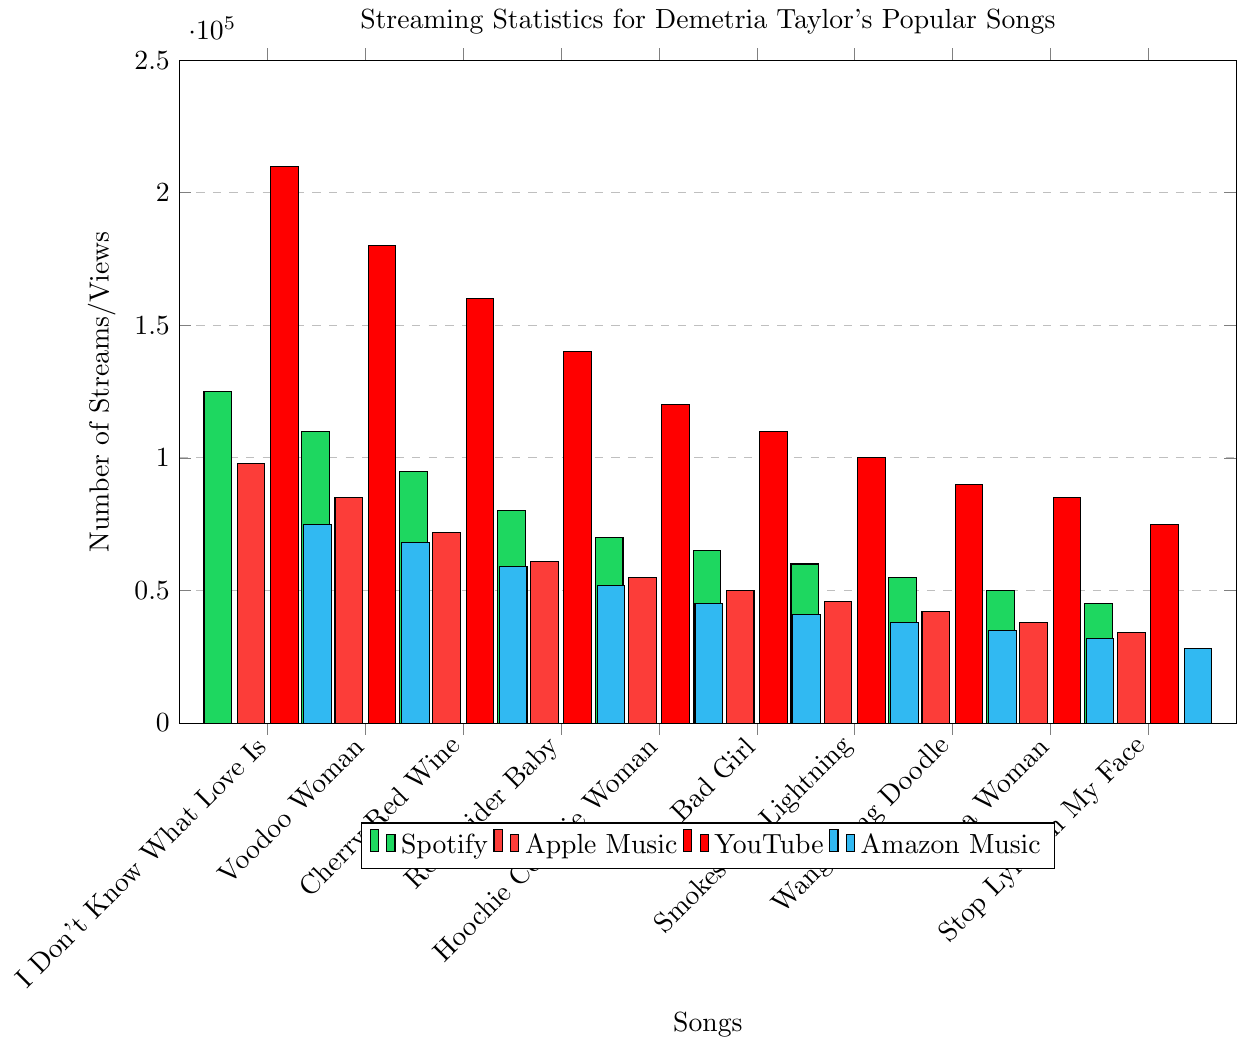Which song has the highest number of YouTube views? The heights of the bars in red (YouTube) indicate the number of views. The tallest red bar corresponds to the song "I Don't Know What Love Is" with 210,000 views.
Answer: "I Don't Know What Love Is" What is the sum of Spotify streams for "Voodoo Woman" and "Cherry Red Wine"? Add the number of Spotify streams for "Voodoo Woman" (110,000) and "Cherry Red Wine" (95,000). The sum is 110,000 + 95,000 = 205,000.
Answer: 205,000 Which song has the smallest number of Amazon Music streams? The heights of the bars in blue (Amazon Music) are compared to determine the smallest. The shortest blue bar corresponds to "Stop Lying in My Face" with 28,000 streams.
Answer: "Stop Lying in My Face" How does the number of Apple Music plays for "Bad Girl" compare to "Hoochie Coochie Woman"? The heights of bars in red for "Bad Girl" and "Hoochie Coochie Woman" are compared. "Bad Girl" has 50,000 plays, and "Hoochie Coochie Woman" has 55,000 plays, so "Bad Girl" has fewer plays.
Answer: Fewer Which song has more Spotify streams, "Smokestack Lightning" or "Wang Dang Doodle"? The heights of the green bars for both songs are compared. "Smokestack Lightning" has 60,000 streams, and "Wang Dang Doodle" has 55,000 streams, so "Smokestack Lightning" has more.
Answer: "Smokestack Lightning" What is the average number of YouTube views across all songs? First, add up all the YouTube views: 210,000 + 180,000 + 160,000 + 140,000 + 120,000 + 110,000 + 100,000 + 90,000 + 85,000 + 75,000 = 1,270,000. Then, divide by the number of songs (10). The average is 1,270,000 / 10 = 127,000.
Answer: 127,000 Which song has almost equal Spotify and Apple Music plays? Compare the heights of green and red bars for each song. "Cherry Red Wine" has 95,000 Spotify streams and 72,000 Apple Music plays, which are the closest in value among all songs.
Answer: "Cherry Red Wine" What is the difference in Amazon Music streams between "I'm a Woman" and "Stop Lying in My Face"? Subtract the number of Amazon Music streams for "Stop Lying in My Face" (28,000) from "I'm a Woman" (32,000). The difference is 32,000 - 28,000 = 4,000.
Answer: 4,000 Identify the song with the highest total streams across all platforms. Calculate the total streams for each song by summing up the streams/views for Spotify, Apple Music, YouTube, and Amazon Music. The song with the highest total will be the one with the sum:
"I Don't Know What Love Is" = 125,000 + 98,000 + 210,000 + 75,000 = 508,000
"Voodoo Woman" = 110,000 + 85,000 + 180,000 + 68,000 = 443,000
"Cherry Red Wine" = 95,000 + 72,000 + 160,000 + 59,000 = 386,000
"Reconsider Baby" = 80,000 + 61,000 + 140,000 + 52,000 = 333,000
"Hoochie Coochie Woman" = 70,000 + 55,000 + 120,000 + 45,000 = 290,000
"Bad Girl" = 65,000 + 50,000 + 110,000 + 41,000 = 266,000
"Smokestack Lightning" = 60,000 + 46,000 + 100,000 + 38,000 = 244,000
"Wang Dang Doodle" = 55,000 + 42,000 + 90,000 + 35,000 = 222,000
"I'm a Woman" = 50,000 + 38,000 + 85,000 + 32,000 = 205,000
"Stop Lying in My Face" = 45,000 + 34,000 + 75,000 + 28,000 = 182,000
"I Don't Know What Love Is" has the highest total streams.
Answer: "I Don't Know What Love Is" 